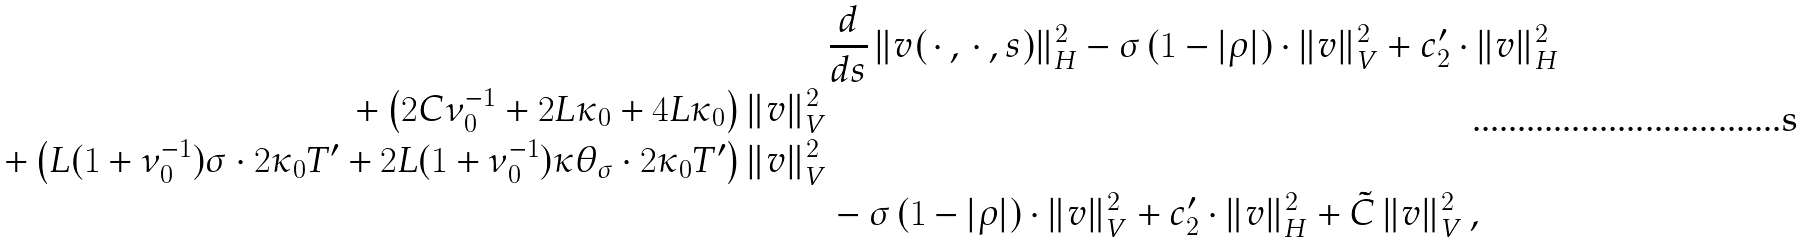<formula> <loc_0><loc_0><loc_500><loc_500>& \frac { d } { d s } \, \| v ( \, \cdot \, , \, \cdot \, , s ) \| _ { H } ^ { 2 } - \sigma \, ( 1 - | \rho | ) \cdot \| v \| _ { V } ^ { 2 } + c _ { 2 } ^ { \prime } \cdot \| v \| _ { H } ^ { 2 } \\ + \left ( 2 C \nu _ { 0 } ^ { - 1 } + 2 L \kappa _ { 0 } + 4 L \kappa _ { 0 } \right ) \| v \| _ { V } ^ { 2 } \\ + \left ( L ( 1 + \nu _ { 0 } ^ { - 1 } ) \sigma \cdot 2 \kappa _ { 0 } T ^ { \prime } + 2 L ( 1 + \nu _ { 0 } ^ { - 1 } ) \kappa \theta _ { \sigma } \cdot 2 \kappa _ { 0 } T ^ { \prime } \right ) \| v \| _ { V } ^ { 2 } \\ & - \sigma \, ( 1 - | \rho | ) \cdot \| v \| _ { V } ^ { 2 } + c _ { 2 } ^ { \prime } \cdot \| v \| _ { H } ^ { 2 } + \tilde { C } \, \| v \| _ { V } ^ { 2 } \, ,</formula> 